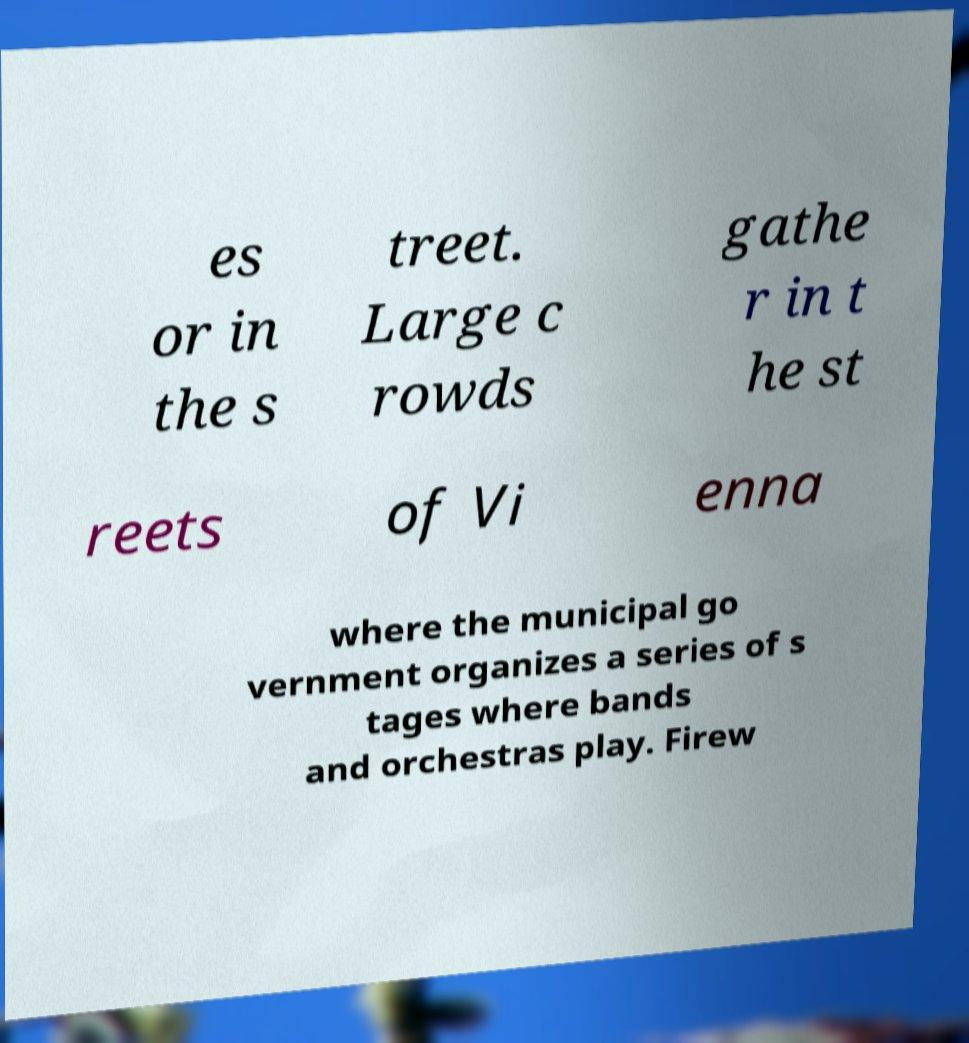Please read and relay the text visible in this image. What does it say? es or in the s treet. Large c rowds gathe r in t he st reets of Vi enna where the municipal go vernment organizes a series of s tages where bands and orchestras play. Firew 